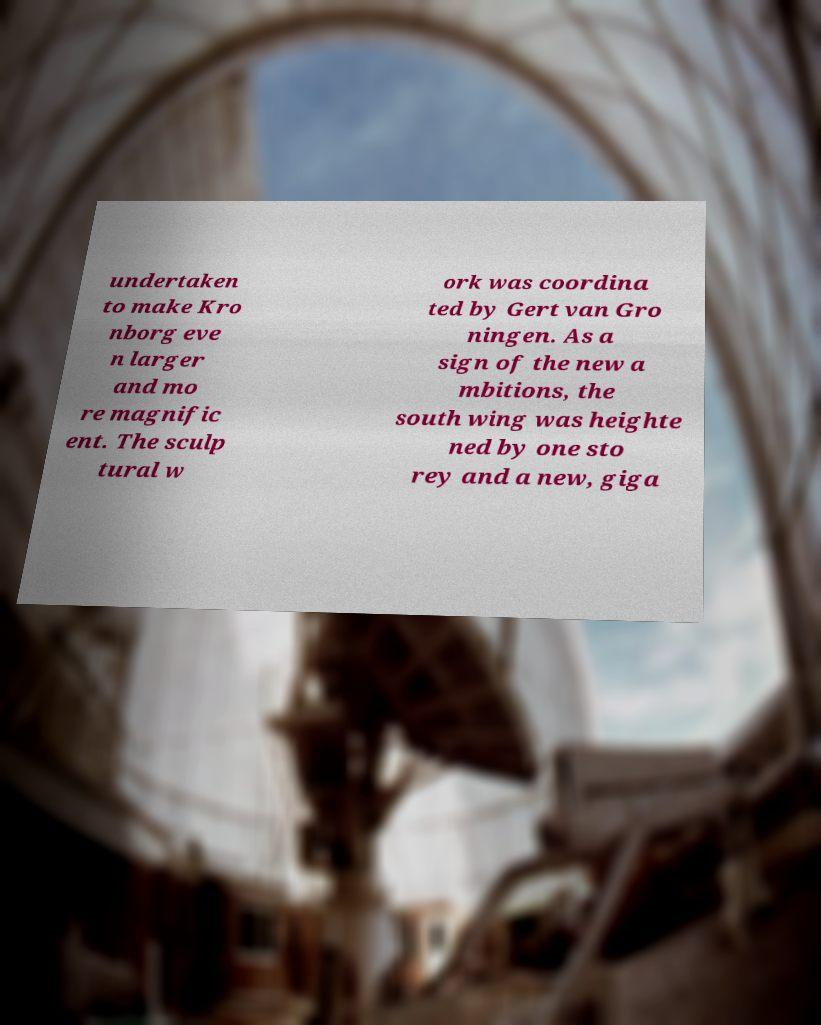Please identify and transcribe the text found in this image. undertaken to make Kro nborg eve n larger and mo re magnific ent. The sculp tural w ork was coordina ted by Gert van Gro ningen. As a sign of the new a mbitions, the south wing was heighte ned by one sto rey and a new, giga 